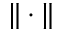<formula> <loc_0><loc_0><loc_500><loc_500>\| \cdot \|</formula> 